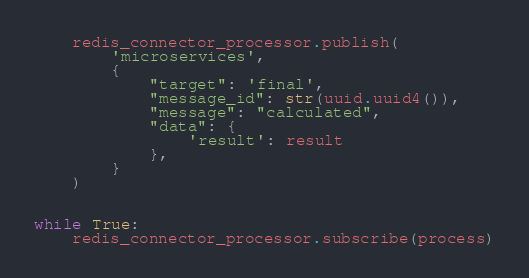<code> <loc_0><loc_0><loc_500><loc_500><_Python_>    redis_connector_processor.publish(
        'microservices',
        {
            "target": 'final',
            "message_id": str(uuid.uuid4()),
            "message": "calculated",
            "data": {
                'result': result
            },
        }
    )


while True:
    redis_connector_processor.subscribe(process)
</code> 